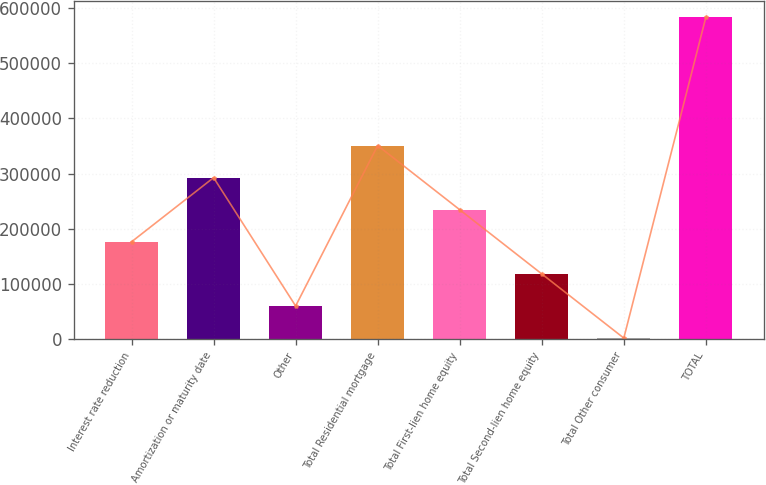Convert chart. <chart><loc_0><loc_0><loc_500><loc_500><bar_chart><fcel>Interest rate reduction<fcel>Amortization or maturity date<fcel>Other<fcel>Total Residential mortgage<fcel>Total First-lien home equity<fcel>Total Second-lien home equity<fcel>Total Other consumer<fcel>TOTAL<nl><fcel>176116<fcel>292494<fcel>59738<fcel>350683<fcel>234305<fcel>117927<fcel>1549<fcel>583439<nl></chart> 